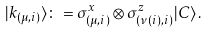<formula> <loc_0><loc_0><loc_500><loc_500>| k _ { ( \mu , i ) } \rangle \colon = \sigma ^ { x } _ { ( \mu , i ) } \otimes \sigma ^ { z } _ { ( \nu ( i ) , i ) } | C \rangle \, .</formula> 